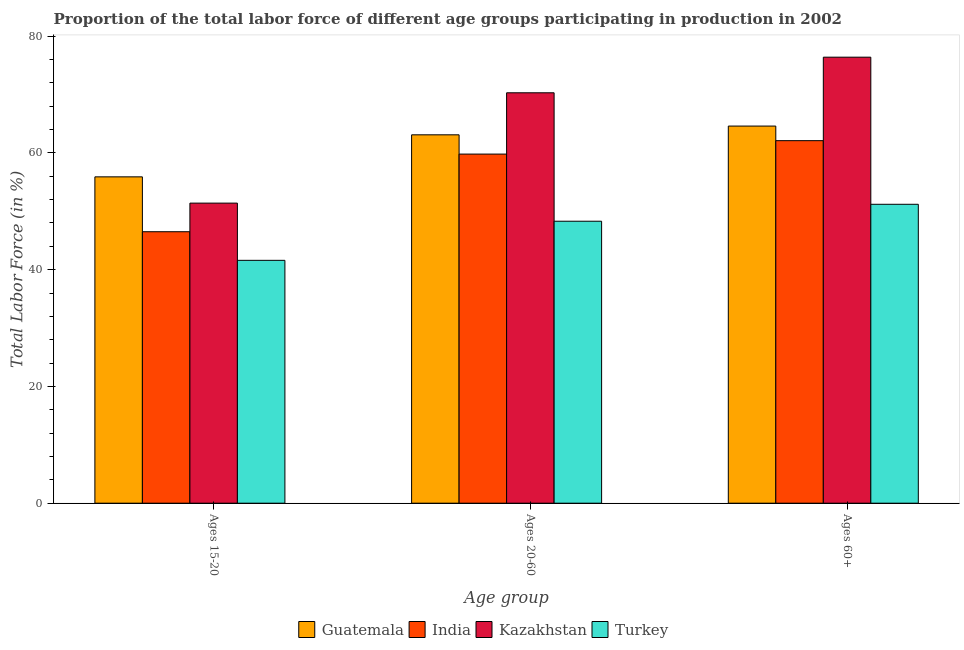How many groups of bars are there?
Provide a short and direct response. 3. Are the number of bars on each tick of the X-axis equal?
Give a very brief answer. Yes. How many bars are there on the 2nd tick from the right?
Provide a succinct answer. 4. What is the label of the 1st group of bars from the left?
Provide a short and direct response. Ages 15-20. What is the percentage of labor force within the age group 20-60 in Turkey?
Keep it short and to the point. 48.3. Across all countries, what is the maximum percentage of labor force within the age group 15-20?
Make the answer very short. 55.9. Across all countries, what is the minimum percentage of labor force within the age group 20-60?
Your answer should be very brief. 48.3. In which country was the percentage of labor force within the age group 20-60 maximum?
Offer a very short reply. Kazakhstan. What is the total percentage of labor force within the age group 15-20 in the graph?
Provide a succinct answer. 195.4. What is the difference between the percentage of labor force within the age group 15-20 in Kazakhstan and the percentage of labor force within the age group 20-60 in India?
Provide a short and direct response. -8.4. What is the average percentage of labor force above age 60 per country?
Provide a succinct answer. 63.57. What is the difference between the percentage of labor force within the age group 20-60 and percentage of labor force above age 60 in Guatemala?
Offer a very short reply. -1.5. In how many countries, is the percentage of labor force above age 60 greater than 48 %?
Give a very brief answer. 4. What is the ratio of the percentage of labor force within the age group 15-20 in Kazakhstan to that in India?
Make the answer very short. 1.11. Is the percentage of labor force above age 60 in Kazakhstan less than that in Turkey?
Offer a very short reply. No. Is the difference between the percentage of labor force within the age group 20-60 in Kazakhstan and India greater than the difference between the percentage of labor force above age 60 in Kazakhstan and India?
Offer a very short reply. No. What is the difference between the highest and the second highest percentage of labor force above age 60?
Give a very brief answer. 11.8. What is the difference between the highest and the lowest percentage of labor force within the age group 15-20?
Give a very brief answer. 14.3. In how many countries, is the percentage of labor force within the age group 20-60 greater than the average percentage of labor force within the age group 20-60 taken over all countries?
Provide a succinct answer. 2. Is the sum of the percentage of labor force within the age group 15-20 in Guatemala and Kazakhstan greater than the maximum percentage of labor force within the age group 20-60 across all countries?
Your response must be concise. Yes. What does the 1st bar from the left in Ages 60+ represents?
Keep it short and to the point. Guatemala. What does the 4th bar from the right in Ages 15-20 represents?
Provide a succinct answer. Guatemala. Is it the case that in every country, the sum of the percentage of labor force within the age group 15-20 and percentage of labor force within the age group 20-60 is greater than the percentage of labor force above age 60?
Make the answer very short. Yes. How many bars are there?
Ensure brevity in your answer.  12. Are all the bars in the graph horizontal?
Provide a succinct answer. No. How many countries are there in the graph?
Provide a succinct answer. 4. Where does the legend appear in the graph?
Provide a succinct answer. Bottom center. How are the legend labels stacked?
Offer a terse response. Horizontal. What is the title of the graph?
Your answer should be very brief. Proportion of the total labor force of different age groups participating in production in 2002. Does "Iceland" appear as one of the legend labels in the graph?
Offer a very short reply. No. What is the label or title of the X-axis?
Your answer should be very brief. Age group. What is the label or title of the Y-axis?
Provide a succinct answer. Total Labor Force (in %). What is the Total Labor Force (in %) in Guatemala in Ages 15-20?
Make the answer very short. 55.9. What is the Total Labor Force (in %) of India in Ages 15-20?
Offer a terse response. 46.5. What is the Total Labor Force (in %) in Kazakhstan in Ages 15-20?
Offer a terse response. 51.4. What is the Total Labor Force (in %) in Turkey in Ages 15-20?
Your answer should be very brief. 41.6. What is the Total Labor Force (in %) in Guatemala in Ages 20-60?
Keep it short and to the point. 63.1. What is the Total Labor Force (in %) in India in Ages 20-60?
Make the answer very short. 59.8. What is the Total Labor Force (in %) in Kazakhstan in Ages 20-60?
Keep it short and to the point. 70.3. What is the Total Labor Force (in %) in Turkey in Ages 20-60?
Ensure brevity in your answer.  48.3. What is the Total Labor Force (in %) in Guatemala in Ages 60+?
Provide a succinct answer. 64.6. What is the Total Labor Force (in %) of India in Ages 60+?
Your answer should be very brief. 62.1. What is the Total Labor Force (in %) in Kazakhstan in Ages 60+?
Make the answer very short. 76.4. What is the Total Labor Force (in %) of Turkey in Ages 60+?
Give a very brief answer. 51.2. Across all Age group, what is the maximum Total Labor Force (in %) in Guatemala?
Your response must be concise. 64.6. Across all Age group, what is the maximum Total Labor Force (in %) of India?
Offer a terse response. 62.1. Across all Age group, what is the maximum Total Labor Force (in %) in Kazakhstan?
Your answer should be compact. 76.4. Across all Age group, what is the maximum Total Labor Force (in %) in Turkey?
Provide a succinct answer. 51.2. Across all Age group, what is the minimum Total Labor Force (in %) in Guatemala?
Your answer should be compact. 55.9. Across all Age group, what is the minimum Total Labor Force (in %) of India?
Offer a very short reply. 46.5. Across all Age group, what is the minimum Total Labor Force (in %) in Kazakhstan?
Offer a terse response. 51.4. Across all Age group, what is the minimum Total Labor Force (in %) of Turkey?
Ensure brevity in your answer.  41.6. What is the total Total Labor Force (in %) of Guatemala in the graph?
Offer a terse response. 183.6. What is the total Total Labor Force (in %) of India in the graph?
Offer a very short reply. 168.4. What is the total Total Labor Force (in %) in Kazakhstan in the graph?
Offer a terse response. 198.1. What is the total Total Labor Force (in %) of Turkey in the graph?
Your answer should be very brief. 141.1. What is the difference between the Total Labor Force (in %) of India in Ages 15-20 and that in Ages 20-60?
Your response must be concise. -13.3. What is the difference between the Total Labor Force (in %) of Kazakhstan in Ages 15-20 and that in Ages 20-60?
Make the answer very short. -18.9. What is the difference between the Total Labor Force (in %) in Guatemala in Ages 15-20 and that in Ages 60+?
Provide a succinct answer. -8.7. What is the difference between the Total Labor Force (in %) of India in Ages 15-20 and that in Ages 60+?
Your response must be concise. -15.6. What is the difference between the Total Labor Force (in %) in Turkey in Ages 15-20 and that in Ages 60+?
Keep it short and to the point. -9.6. What is the difference between the Total Labor Force (in %) of Guatemala in Ages 20-60 and that in Ages 60+?
Keep it short and to the point. -1.5. What is the difference between the Total Labor Force (in %) in India in Ages 20-60 and that in Ages 60+?
Provide a short and direct response. -2.3. What is the difference between the Total Labor Force (in %) of Kazakhstan in Ages 20-60 and that in Ages 60+?
Your answer should be compact. -6.1. What is the difference between the Total Labor Force (in %) in Guatemala in Ages 15-20 and the Total Labor Force (in %) in India in Ages 20-60?
Ensure brevity in your answer.  -3.9. What is the difference between the Total Labor Force (in %) in Guatemala in Ages 15-20 and the Total Labor Force (in %) in Kazakhstan in Ages 20-60?
Offer a terse response. -14.4. What is the difference between the Total Labor Force (in %) in Guatemala in Ages 15-20 and the Total Labor Force (in %) in Turkey in Ages 20-60?
Keep it short and to the point. 7.6. What is the difference between the Total Labor Force (in %) in India in Ages 15-20 and the Total Labor Force (in %) in Kazakhstan in Ages 20-60?
Provide a short and direct response. -23.8. What is the difference between the Total Labor Force (in %) in Guatemala in Ages 15-20 and the Total Labor Force (in %) in Kazakhstan in Ages 60+?
Offer a terse response. -20.5. What is the difference between the Total Labor Force (in %) of Guatemala in Ages 15-20 and the Total Labor Force (in %) of Turkey in Ages 60+?
Give a very brief answer. 4.7. What is the difference between the Total Labor Force (in %) in India in Ages 15-20 and the Total Labor Force (in %) in Kazakhstan in Ages 60+?
Give a very brief answer. -29.9. What is the difference between the Total Labor Force (in %) in India in Ages 15-20 and the Total Labor Force (in %) in Turkey in Ages 60+?
Give a very brief answer. -4.7. What is the difference between the Total Labor Force (in %) in Kazakhstan in Ages 15-20 and the Total Labor Force (in %) in Turkey in Ages 60+?
Give a very brief answer. 0.2. What is the difference between the Total Labor Force (in %) in Guatemala in Ages 20-60 and the Total Labor Force (in %) in India in Ages 60+?
Offer a very short reply. 1. What is the difference between the Total Labor Force (in %) in Guatemala in Ages 20-60 and the Total Labor Force (in %) in Kazakhstan in Ages 60+?
Make the answer very short. -13.3. What is the difference between the Total Labor Force (in %) in Guatemala in Ages 20-60 and the Total Labor Force (in %) in Turkey in Ages 60+?
Keep it short and to the point. 11.9. What is the difference between the Total Labor Force (in %) of India in Ages 20-60 and the Total Labor Force (in %) of Kazakhstan in Ages 60+?
Offer a terse response. -16.6. What is the difference between the Total Labor Force (in %) in India in Ages 20-60 and the Total Labor Force (in %) in Turkey in Ages 60+?
Provide a succinct answer. 8.6. What is the average Total Labor Force (in %) in Guatemala per Age group?
Your answer should be very brief. 61.2. What is the average Total Labor Force (in %) of India per Age group?
Provide a succinct answer. 56.13. What is the average Total Labor Force (in %) in Kazakhstan per Age group?
Ensure brevity in your answer.  66.03. What is the average Total Labor Force (in %) of Turkey per Age group?
Make the answer very short. 47.03. What is the difference between the Total Labor Force (in %) in Guatemala and Total Labor Force (in %) in Kazakhstan in Ages 15-20?
Your response must be concise. 4.5. What is the difference between the Total Labor Force (in %) in Guatemala and Total Labor Force (in %) in Turkey in Ages 15-20?
Give a very brief answer. 14.3. What is the difference between the Total Labor Force (in %) in India and Total Labor Force (in %) in Turkey in Ages 15-20?
Provide a short and direct response. 4.9. What is the difference between the Total Labor Force (in %) in Guatemala and Total Labor Force (in %) in India in Ages 20-60?
Make the answer very short. 3.3. What is the difference between the Total Labor Force (in %) of Guatemala and Total Labor Force (in %) of Turkey in Ages 20-60?
Make the answer very short. 14.8. What is the difference between the Total Labor Force (in %) of India and Total Labor Force (in %) of Kazakhstan in Ages 20-60?
Your answer should be compact. -10.5. What is the difference between the Total Labor Force (in %) of India and Total Labor Force (in %) of Turkey in Ages 20-60?
Ensure brevity in your answer.  11.5. What is the difference between the Total Labor Force (in %) of Guatemala and Total Labor Force (in %) of India in Ages 60+?
Your answer should be compact. 2.5. What is the difference between the Total Labor Force (in %) in Guatemala and Total Labor Force (in %) in Turkey in Ages 60+?
Your response must be concise. 13.4. What is the difference between the Total Labor Force (in %) of India and Total Labor Force (in %) of Kazakhstan in Ages 60+?
Your response must be concise. -14.3. What is the difference between the Total Labor Force (in %) of Kazakhstan and Total Labor Force (in %) of Turkey in Ages 60+?
Make the answer very short. 25.2. What is the ratio of the Total Labor Force (in %) of Guatemala in Ages 15-20 to that in Ages 20-60?
Ensure brevity in your answer.  0.89. What is the ratio of the Total Labor Force (in %) of India in Ages 15-20 to that in Ages 20-60?
Make the answer very short. 0.78. What is the ratio of the Total Labor Force (in %) of Kazakhstan in Ages 15-20 to that in Ages 20-60?
Give a very brief answer. 0.73. What is the ratio of the Total Labor Force (in %) in Turkey in Ages 15-20 to that in Ages 20-60?
Your answer should be compact. 0.86. What is the ratio of the Total Labor Force (in %) in Guatemala in Ages 15-20 to that in Ages 60+?
Provide a succinct answer. 0.87. What is the ratio of the Total Labor Force (in %) in India in Ages 15-20 to that in Ages 60+?
Your response must be concise. 0.75. What is the ratio of the Total Labor Force (in %) of Kazakhstan in Ages 15-20 to that in Ages 60+?
Offer a very short reply. 0.67. What is the ratio of the Total Labor Force (in %) in Turkey in Ages 15-20 to that in Ages 60+?
Offer a very short reply. 0.81. What is the ratio of the Total Labor Force (in %) in Guatemala in Ages 20-60 to that in Ages 60+?
Provide a succinct answer. 0.98. What is the ratio of the Total Labor Force (in %) of Kazakhstan in Ages 20-60 to that in Ages 60+?
Your response must be concise. 0.92. What is the ratio of the Total Labor Force (in %) in Turkey in Ages 20-60 to that in Ages 60+?
Your answer should be very brief. 0.94. What is the difference between the highest and the second highest Total Labor Force (in %) of Guatemala?
Keep it short and to the point. 1.5. What is the difference between the highest and the lowest Total Labor Force (in %) in India?
Offer a very short reply. 15.6. What is the difference between the highest and the lowest Total Labor Force (in %) in Kazakhstan?
Your response must be concise. 25. 